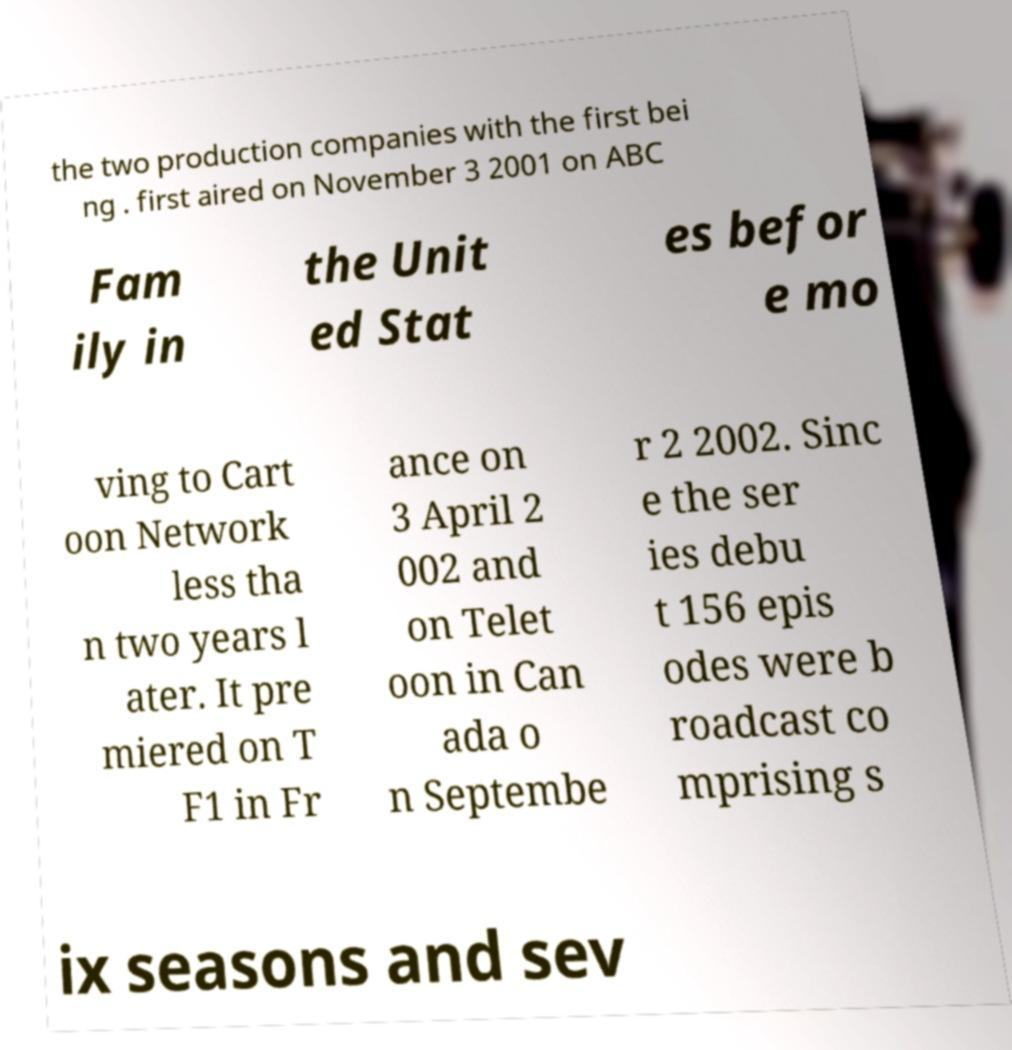I need the written content from this picture converted into text. Can you do that? the two production companies with the first bei ng . first aired on November 3 2001 on ABC Fam ily in the Unit ed Stat es befor e mo ving to Cart oon Network less tha n two years l ater. It pre miered on T F1 in Fr ance on 3 April 2 002 and on Telet oon in Can ada o n Septembe r 2 2002. Sinc e the ser ies debu t 156 epis odes were b roadcast co mprising s ix seasons and sev 